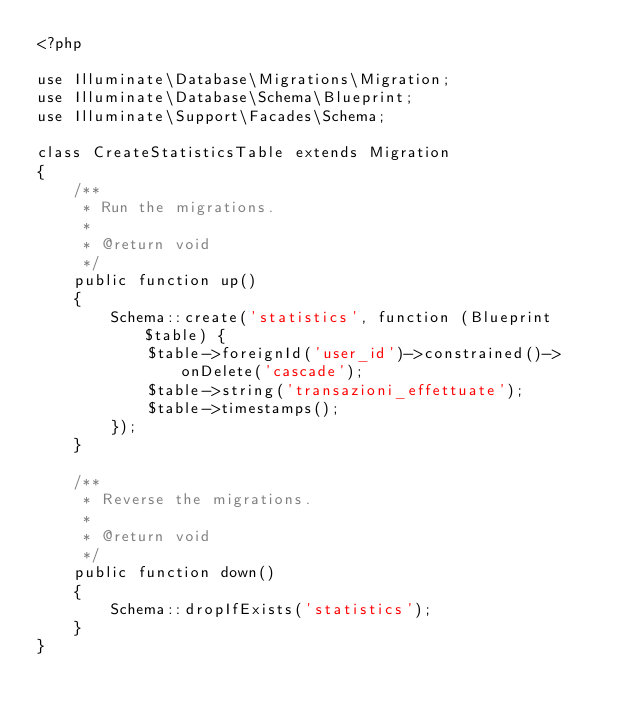Convert code to text. <code><loc_0><loc_0><loc_500><loc_500><_PHP_><?php

use Illuminate\Database\Migrations\Migration;
use Illuminate\Database\Schema\Blueprint;
use Illuminate\Support\Facades\Schema;

class CreateStatisticsTable extends Migration
{
    /**
     * Run the migrations.
     *
     * @return void
     */
    public function up()
    {
        Schema::create('statistics', function (Blueprint $table) {
            $table->foreignId('user_id')->constrained()->onDelete('cascade');
            $table->string('transazioni_effettuate');
            $table->timestamps();
        });
    }

    /**
     * Reverse the migrations.
     *
     * @return void
     */
    public function down()
    {
        Schema::dropIfExists('statistics');
    }
}
</code> 